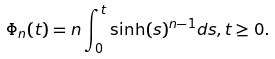<formula> <loc_0><loc_0><loc_500><loc_500>\Phi _ { n } ( t ) = n \int _ { 0 } ^ { t } \sinh ( s ) ^ { n - 1 } d s , t \geq 0 .</formula> 